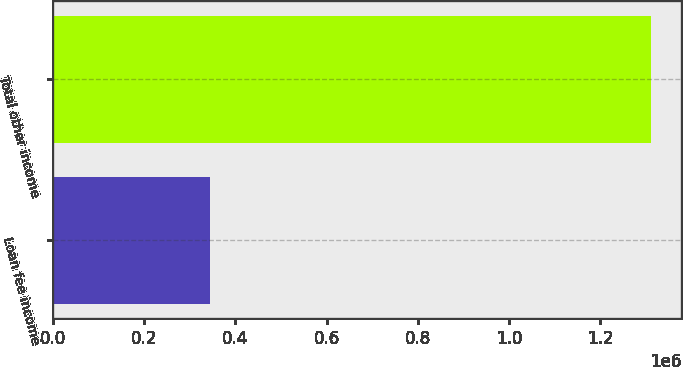Convert chart to OTSL. <chart><loc_0><loc_0><loc_500><loc_500><bar_chart><fcel>Loan fee income<fcel>Total other income<nl><fcel>343605<fcel>1.31136e+06<nl></chart> 